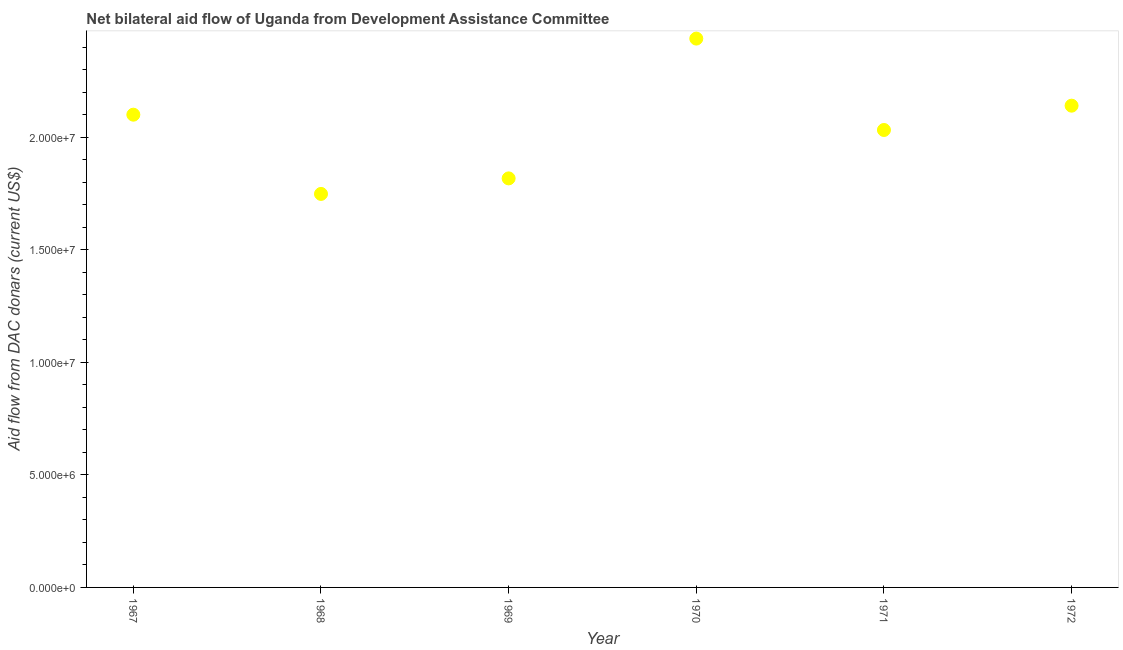What is the net bilateral aid flows from dac donors in 1971?
Offer a terse response. 2.03e+07. Across all years, what is the maximum net bilateral aid flows from dac donors?
Your answer should be compact. 2.44e+07. Across all years, what is the minimum net bilateral aid flows from dac donors?
Make the answer very short. 1.75e+07. In which year was the net bilateral aid flows from dac donors minimum?
Your answer should be very brief. 1968. What is the sum of the net bilateral aid flows from dac donors?
Make the answer very short. 1.23e+08. What is the difference between the net bilateral aid flows from dac donors in 1969 and 1972?
Offer a terse response. -3.23e+06. What is the average net bilateral aid flows from dac donors per year?
Give a very brief answer. 2.05e+07. What is the median net bilateral aid flows from dac donors?
Give a very brief answer. 2.07e+07. In how many years, is the net bilateral aid flows from dac donors greater than 18000000 US$?
Make the answer very short. 5. What is the ratio of the net bilateral aid flows from dac donors in 1969 to that in 1970?
Provide a short and direct response. 0.75. Is the difference between the net bilateral aid flows from dac donors in 1968 and 1971 greater than the difference between any two years?
Your answer should be compact. No. What is the difference between the highest and the second highest net bilateral aid flows from dac donors?
Your response must be concise. 2.98e+06. Is the sum of the net bilateral aid flows from dac donors in 1969 and 1970 greater than the maximum net bilateral aid flows from dac donors across all years?
Give a very brief answer. Yes. What is the difference between the highest and the lowest net bilateral aid flows from dac donors?
Your answer should be very brief. 6.90e+06. In how many years, is the net bilateral aid flows from dac donors greater than the average net bilateral aid flows from dac donors taken over all years?
Your response must be concise. 3. Does the net bilateral aid flows from dac donors monotonically increase over the years?
Keep it short and to the point. No. How many dotlines are there?
Make the answer very short. 1. What is the difference between two consecutive major ticks on the Y-axis?
Your response must be concise. 5.00e+06. What is the title of the graph?
Provide a short and direct response. Net bilateral aid flow of Uganda from Development Assistance Committee. What is the label or title of the X-axis?
Offer a very short reply. Year. What is the label or title of the Y-axis?
Ensure brevity in your answer.  Aid flow from DAC donars (current US$). What is the Aid flow from DAC donars (current US$) in 1967?
Provide a succinct answer. 2.10e+07. What is the Aid flow from DAC donars (current US$) in 1968?
Your answer should be very brief. 1.75e+07. What is the Aid flow from DAC donars (current US$) in 1969?
Give a very brief answer. 1.82e+07. What is the Aid flow from DAC donars (current US$) in 1970?
Offer a very short reply. 2.44e+07. What is the Aid flow from DAC donars (current US$) in 1971?
Your response must be concise. 2.03e+07. What is the Aid flow from DAC donars (current US$) in 1972?
Keep it short and to the point. 2.14e+07. What is the difference between the Aid flow from DAC donars (current US$) in 1967 and 1968?
Offer a terse response. 3.52e+06. What is the difference between the Aid flow from DAC donars (current US$) in 1967 and 1969?
Offer a very short reply. 2.83e+06. What is the difference between the Aid flow from DAC donars (current US$) in 1967 and 1970?
Your answer should be very brief. -3.38e+06. What is the difference between the Aid flow from DAC donars (current US$) in 1967 and 1971?
Your answer should be very brief. 6.80e+05. What is the difference between the Aid flow from DAC donars (current US$) in 1967 and 1972?
Offer a terse response. -4.00e+05. What is the difference between the Aid flow from DAC donars (current US$) in 1968 and 1969?
Ensure brevity in your answer.  -6.90e+05. What is the difference between the Aid flow from DAC donars (current US$) in 1968 and 1970?
Provide a short and direct response. -6.90e+06. What is the difference between the Aid flow from DAC donars (current US$) in 1968 and 1971?
Offer a very short reply. -2.84e+06. What is the difference between the Aid flow from DAC donars (current US$) in 1968 and 1972?
Your response must be concise. -3.92e+06. What is the difference between the Aid flow from DAC donars (current US$) in 1969 and 1970?
Your answer should be very brief. -6.21e+06. What is the difference between the Aid flow from DAC donars (current US$) in 1969 and 1971?
Your answer should be very brief. -2.15e+06. What is the difference between the Aid flow from DAC donars (current US$) in 1969 and 1972?
Offer a very short reply. -3.23e+06. What is the difference between the Aid flow from DAC donars (current US$) in 1970 and 1971?
Your answer should be compact. 4.06e+06. What is the difference between the Aid flow from DAC donars (current US$) in 1970 and 1972?
Your answer should be very brief. 2.98e+06. What is the difference between the Aid flow from DAC donars (current US$) in 1971 and 1972?
Make the answer very short. -1.08e+06. What is the ratio of the Aid flow from DAC donars (current US$) in 1967 to that in 1968?
Offer a very short reply. 1.2. What is the ratio of the Aid flow from DAC donars (current US$) in 1967 to that in 1969?
Give a very brief answer. 1.16. What is the ratio of the Aid flow from DAC donars (current US$) in 1967 to that in 1970?
Offer a terse response. 0.86. What is the ratio of the Aid flow from DAC donars (current US$) in 1967 to that in 1971?
Your answer should be very brief. 1.03. What is the ratio of the Aid flow from DAC donars (current US$) in 1967 to that in 1972?
Your answer should be very brief. 0.98. What is the ratio of the Aid flow from DAC donars (current US$) in 1968 to that in 1970?
Your response must be concise. 0.72. What is the ratio of the Aid flow from DAC donars (current US$) in 1968 to that in 1971?
Your answer should be compact. 0.86. What is the ratio of the Aid flow from DAC donars (current US$) in 1968 to that in 1972?
Make the answer very short. 0.82. What is the ratio of the Aid flow from DAC donars (current US$) in 1969 to that in 1970?
Give a very brief answer. 0.74. What is the ratio of the Aid flow from DAC donars (current US$) in 1969 to that in 1971?
Offer a very short reply. 0.89. What is the ratio of the Aid flow from DAC donars (current US$) in 1969 to that in 1972?
Provide a short and direct response. 0.85. What is the ratio of the Aid flow from DAC donars (current US$) in 1970 to that in 1971?
Provide a short and direct response. 1.2. What is the ratio of the Aid flow from DAC donars (current US$) in 1970 to that in 1972?
Your response must be concise. 1.14. 